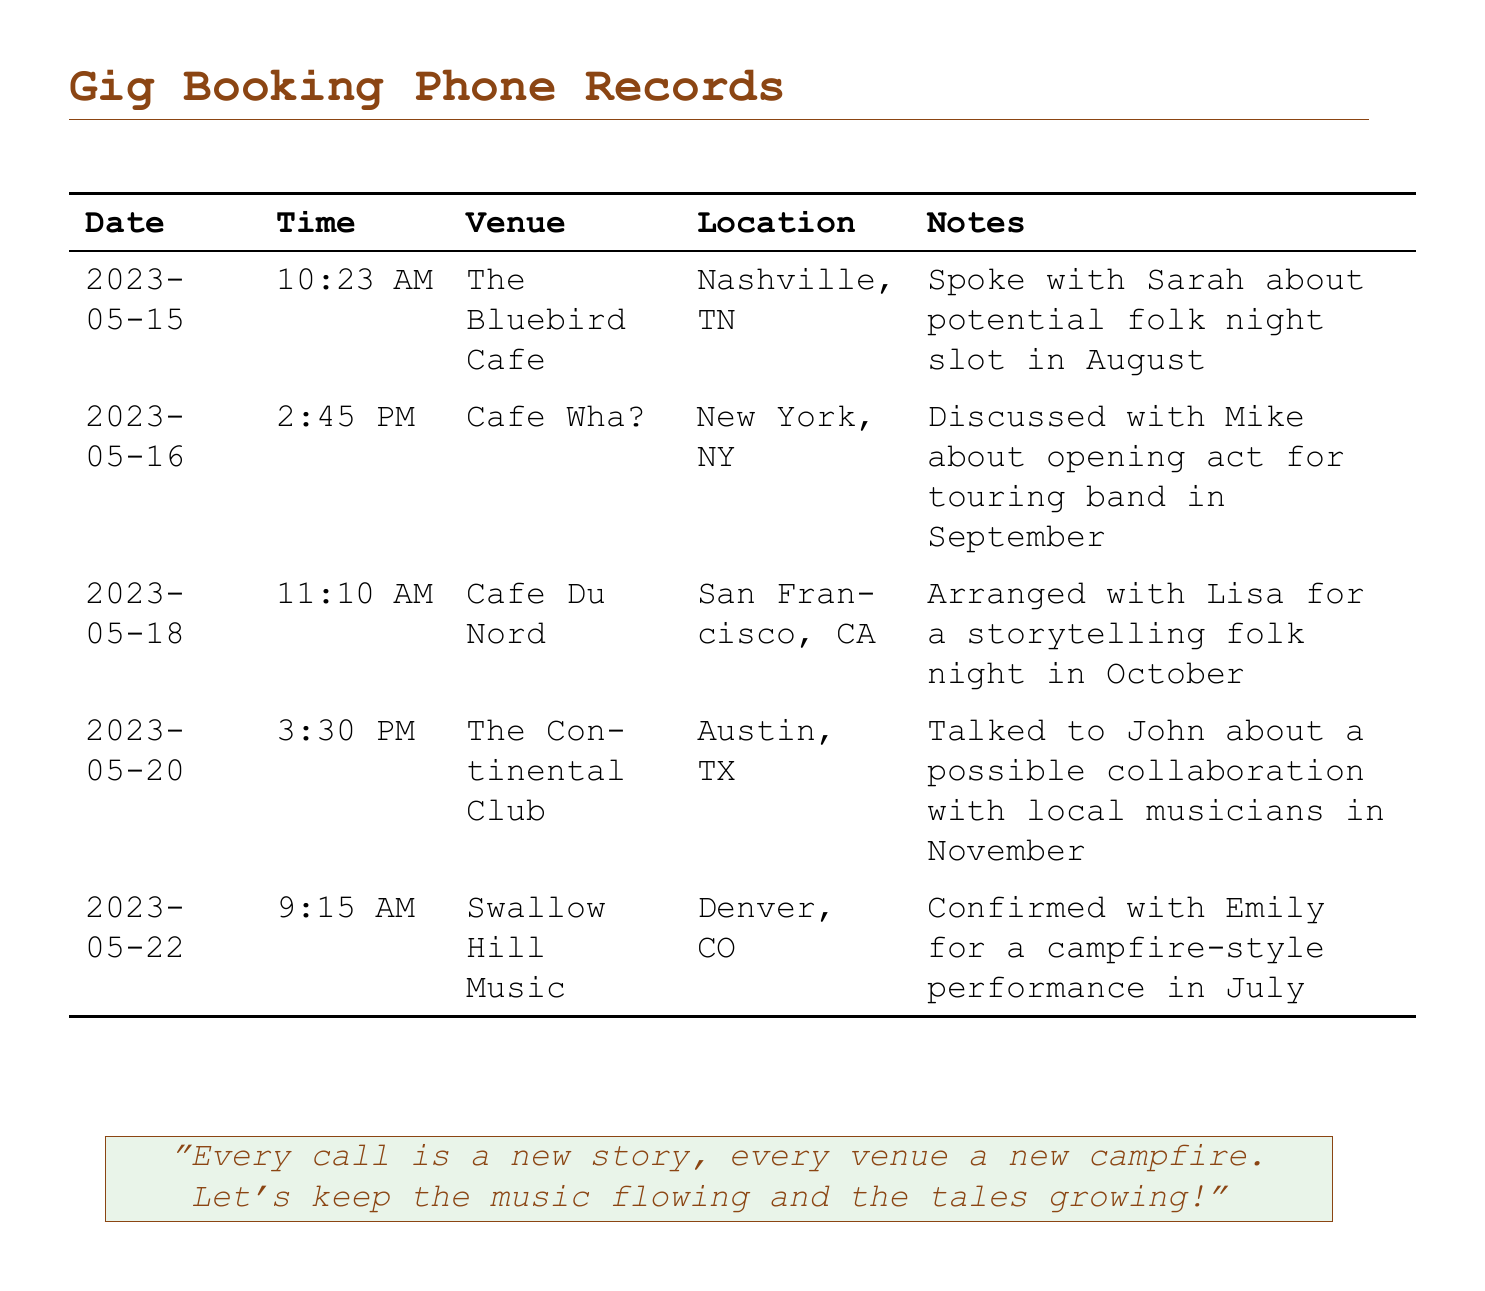What is the date of the call to The Bluebird Cafe? The call to The Bluebird Cafe occurred on May 15, 2023.
Answer: May 15, 2023 Who did the musician speak with at Cafe Du Nord? The musician spoke with Lisa at Cafe Du Nord.
Answer: Lisa What time was the call made to Swallow Hill Music? The call to Swallow Hill Music was made at 9:15 AM.
Answer: 9:15 AM Which venue is located in Austin, TX? The venue located in Austin, TX is The Continental Club.
Answer: The Continental Club What type of performance was confirmed at Swallow Hill Music? The performance at Swallow Hill Music was a campfire-style performance.
Answer: campfire-style performance Which location had a storytelling folk night arranged? The storytelling folk night was arranged at Cafe Du Nord in San Francisco, CA.
Answer: San Francisco, CA How many venues are listed in the document? There are five venues listed in the document.
Answer: five What month is the potential folk night slot at The Bluebird Cafe? The potential folk night slot at The Bluebird Cafe is in August.
Answer: August What was discussed with Mike at Cafe Wha?? The discussion with Mike at Cafe Wha? was about an opening act for a touring band.
Answer: opening act for touring band 